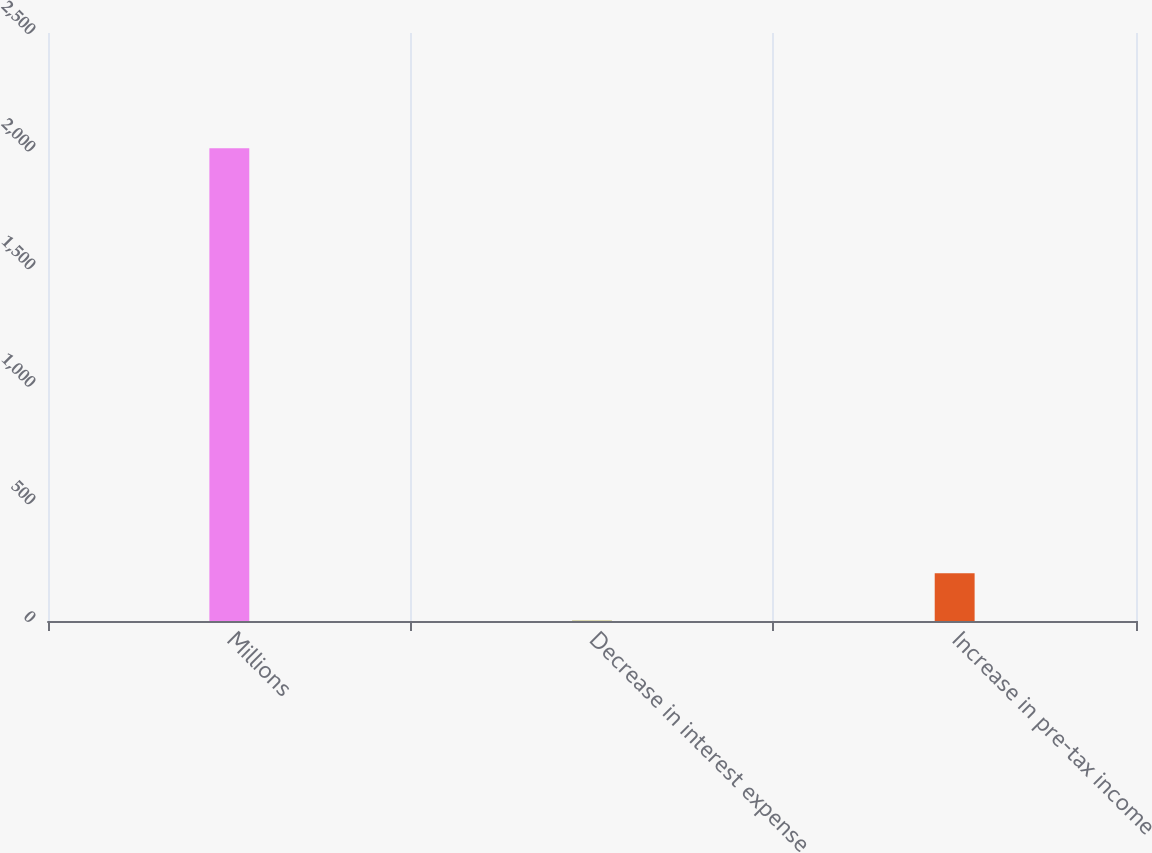<chart> <loc_0><loc_0><loc_500><loc_500><bar_chart><fcel>Millions<fcel>Decrease in interest expense<fcel>Increase in pre-tax income<nl><fcel>2010<fcel>2<fcel>202.8<nl></chart> 